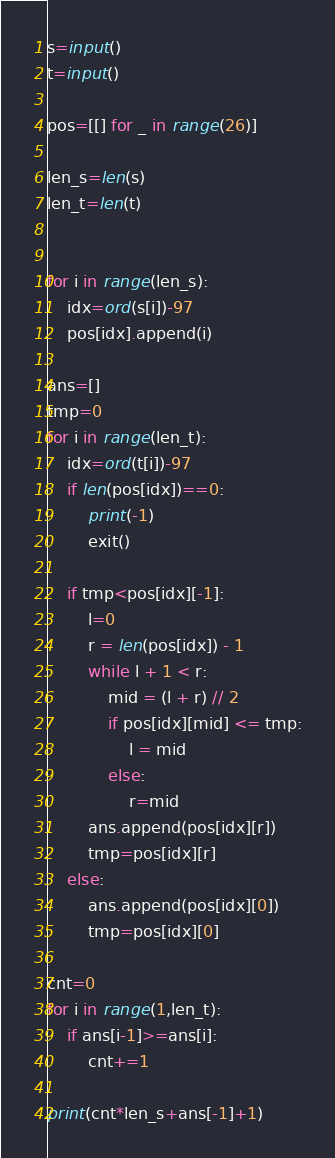<code> <loc_0><loc_0><loc_500><loc_500><_Python_>s=input()
t=input()

pos=[[] for _ in range(26)]

len_s=len(s)
len_t=len(t)


for i in range(len_s):
    idx=ord(s[i])-97
    pos[idx].append(i)

ans=[]
tmp=0
for i in range(len_t):
    idx=ord(t[i])-97
    if len(pos[idx])==0:
        print(-1)
        exit()

    if tmp<pos[idx][-1]:
        l=0
        r = len(pos[idx]) - 1
        while l + 1 < r:
            mid = (l + r) // 2
            if pos[idx][mid] <= tmp:
                l = mid
            else:
                r=mid
        ans.append(pos[idx][r])
        tmp=pos[idx][r]
    else:
        ans.append(pos[idx][0])
        tmp=pos[idx][0]

cnt=0
for i in range(1,len_t):
    if ans[i-1]>=ans[i]:
        cnt+=1

print(cnt*len_s+ans[-1]+1)


</code> 